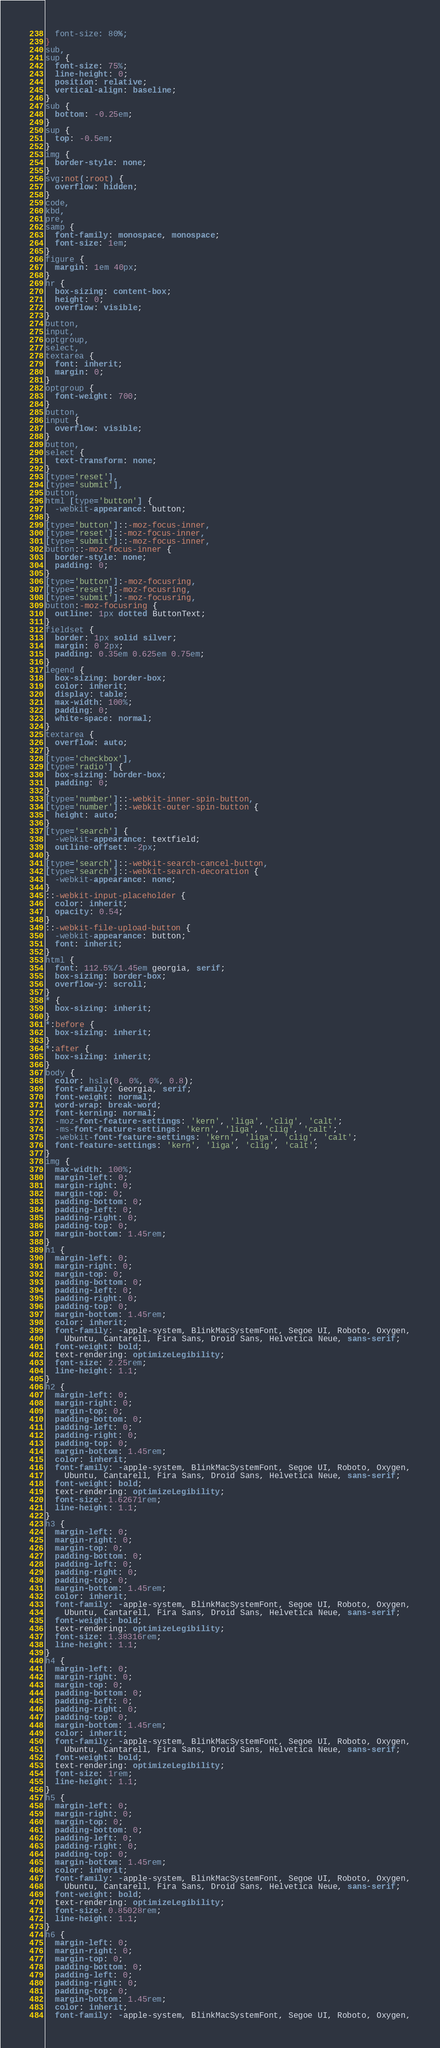<code> <loc_0><loc_0><loc_500><loc_500><_CSS_>  font-size: 80%;
}
sub,
sup {
  font-size: 75%;
  line-height: 0;
  position: relative;
  vertical-align: baseline;
}
sub {
  bottom: -0.25em;
}
sup {
  top: -0.5em;
}
img {
  border-style: none;
}
svg:not(:root) {
  overflow: hidden;
}
code,
kbd,
pre,
samp {
  font-family: monospace, monospace;
  font-size: 1em;
}
figure {
  margin: 1em 40px;
}
hr {
  box-sizing: content-box;
  height: 0;
  overflow: visible;
}
button,
input,
optgroup,
select,
textarea {
  font: inherit;
  margin: 0;
}
optgroup {
  font-weight: 700;
}
button,
input {
  overflow: visible;
}
button,
select {
  text-transform: none;
}
[type='reset'],
[type='submit'],
button,
html [type='button'] {
  -webkit-appearance: button;
}
[type='button']::-moz-focus-inner,
[type='reset']::-moz-focus-inner,
[type='submit']::-moz-focus-inner,
button::-moz-focus-inner {
  border-style: none;
  padding: 0;
}
[type='button']:-moz-focusring,
[type='reset']:-moz-focusring,
[type='submit']:-moz-focusring,
button:-moz-focusring {
  outline: 1px dotted ButtonText;
}
fieldset {
  border: 1px solid silver;
  margin: 0 2px;
  padding: 0.35em 0.625em 0.75em;
}
legend {
  box-sizing: border-box;
  color: inherit;
  display: table;
  max-width: 100%;
  padding: 0;
  white-space: normal;
}
textarea {
  overflow: auto;
}
[type='checkbox'],
[type='radio'] {
  box-sizing: border-box;
  padding: 0;
}
[type='number']::-webkit-inner-spin-button,
[type='number']::-webkit-outer-spin-button {
  height: auto;
}
[type='search'] {
  -webkit-appearance: textfield;
  outline-offset: -2px;
}
[type='search']::-webkit-search-cancel-button,
[type='search']::-webkit-search-decoration {
  -webkit-appearance: none;
}
::-webkit-input-placeholder {
  color: inherit;
  opacity: 0.54;
}
::-webkit-file-upload-button {
  -webkit-appearance: button;
  font: inherit;
}
html {
  font: 112.5%/1.45em georgia, serif;
  box-sizing: border-box;
  overflow-y: scroll;
}
* {
  box-sizing: inherit;
}
*:before {
  box-sizing: inherit;
}
*:after {
  box-sizing: inherit;
}
body {
  color: hsla(0, 0%, 0%, 0.8);
  font-family: Georgia, serif;
  font-weight: normal;
  word-wrap: break-word;
  font-kerning: normal;
  -moz-font-feature-settings: 'kern', 'liga', 'clig', 'calt';
  -ms-font-feature-settings: 'kern', 'liga', 'clig', 'calt';
  -webkit-font-feature-settings: 'kern', 'liga', 'clig', 'calt';
  font-feature-settings: 'kern', 'liga', 'clig', 'calt';
}
img {
  max-width: 100%;
  margin-left: 0;
  margin-right: 0;
  margin-top: 0;
  padding-bottom: 0;
  padding-left: 0;
  padding-right: 0;
  padding-top: 0;
  margin-bottom: 1.45rem;
}
h1 {
  margin-left: 0;
  margin-right: 0;
  margin-top: 0;
  padding-bottom: 0;
  padding-left: 0;
  padding-right: 0;
  padding-top: 0;
  margin-bottom: 1.45rem;
  color: inherit;
  font-family: -apple-system, BlinkMacSystemFont, Segoe UI, Roboto, Oxygen,
    Ubuntu, Cantarell, Fira Sans, Droid Sans, Helvetica Neue, sans-serif;
  font-weight: bold;
  text-rendering: optimizeLegibility;
  font-size: 2.25rem;
  line-height: 1.1;
}
h2 {
  margin-left: 0;
  margin-right: 0;
  margin-top: 0;
  padding-bottom: 0;
  padding-left: 0;
  padding-right: 0;
  padding-top: 0;
  margin-bottom: 1.45rem;
  color: inherit;
  font-family: -apple-system, BlinkMacSystemFont, Segoe UI, Roboto, Oxygen,
    Ubuntu, Cantarell, Fira Sans, Droid Sans, Helvetica Neue, sans-serif;
  font-weight: bold;
  text-rendering: optimizeLegibility;
  font-size: 1.62671rem;
  line-height: 1.1;
}
h3 {
  margin-left: 0;
  margin-right: 0;
  margin-top: 0;
  padding-bottom: 0;
  padding-left: 0;
  padding-right: 0;
  padding-top: 0;
  margin-bottom: 1.45rem;
  color: inherit;
  font-family: -apple-system, BlinkMacSystemFont, Segoe UI, Roboto, Oxygen,
    Ubuntu, Cantarell, Fira Sans, Droid Sans, Helvetica Neue, sans-serif;
  font-weight: bold;
  text-rendering: optimizeLegibility;
  font-size: 1.38316rem;
  line-height: 1.1;
}
h4 {
  margin-left: 0;
  margin-right: 0;
  margin-top: 0;
  padding-bottom: 0;
  padding-left: 0;
  padding-right: 0;
  padding-top: 0;
  margin-bottom: 1.45rem;
  color: inherit;
  font-family: -apple-system, BlinkMacSystemFont, Segoe UI, Roboto, Oxygen,
    Ubuntu, Cantarell, Fira Sans, Droid Sans, Helvetica Neue, sans-serif;
  font-weight: bold;
  text-rendering: optimizeLegibility;
  font-size: 1rem;
  line-height: 1.1;
}
h5 {
  margin-left: 0;
  margin-right: 0;
  margin-top: 0;
  padding-bottom: 0;
  padding-left: 0;
  padding-right: 0;
  padding-top: 0;
  margin-bottom: 1.45rem;
  color: inherit;
  font-family: -apple-system, BlinkMacSystemFont, Segoe UI, Roboto, Oxygen,
    Ubuntu, Cantarell, Fira Sans, Droid Sans, Helvetica Neue, sans-serif;
  font-weight: bold;
  text-rendering: optimizeLegibility;
  font-size: 0.85028rem;
  line-height: 1.1;
}
h6 {
  margin-left: 0;
  margin-right: 0;
  margin-top: 0;
  padding-bottom: 0;
  padding-left: 0;
  padding-right: 0;
  padding-top: 0;
  margin-bottom: 1.45rem;
  color: inherit;
  font-family: -apple-system, BlinkMacSystemFont, Segoe UI, Roboto, Oxygen,</code> 